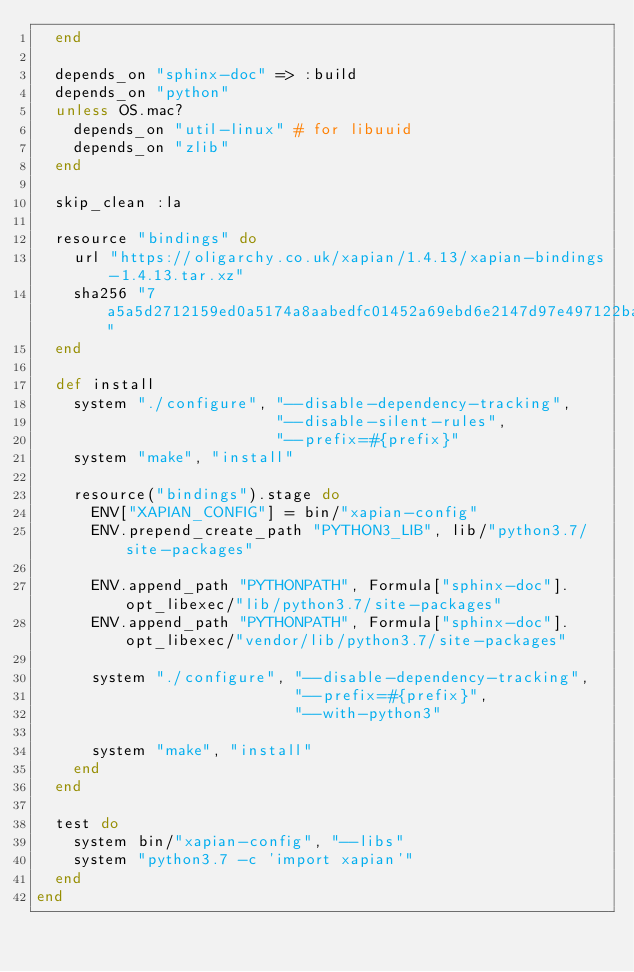<code> <loc_0><loc_0><loc_500><loc_500><_Ruby_>  end

  depends_on "sphinx-doc" => :build
  depends_on "python"
  unless OS.mac?
    depends_on "util-linux" # for libuuid
    depends_on "zlib"
  end

  skip_clean :la

  resource "bindings" do
    url "https://oligarchy.co.uk/xapian/1.4.13/xapian-bindings-1.4.13.tar.xz"
    sha256 "7a5a5d2712159ed0a5174a8aabedfc01452a69ebd6e2147d97e497122baa5892"
  end

  def install
    system "./configure", "--disable-dependency-tracking",
                          "--disable-silent-rules",
                          "--prefix=#{prefix}"
    system "make", "install"

    resource("bindings").stage do
      ENV["XAPIAN_CONFIG"] = bin/"xapian-config"
      ENV.prepend_create_path "PYTHON3_LIB", lib/"python3.7/site-packages"

      ENV.append_path "PYTHONPATH", Formula["sphinx-doc"].opt_libexec/"lib/python3.7/site-packages"
      ENV.append_path "PYTHONPATH", Formula["sphinx-doc"].opt_libexec/"vendor/lib/python3.7/site-packages"

      system "./configure", "--disable-dependency-tracking",
                            "--prefix=#{prefix}",
                            "--with-python3"

      system "make", "install"
    end
  end

  test do
    system bin/"xapian-config", "--libs"
    system "python3.7 -c 'import xapian'"
  end
end
</code> 